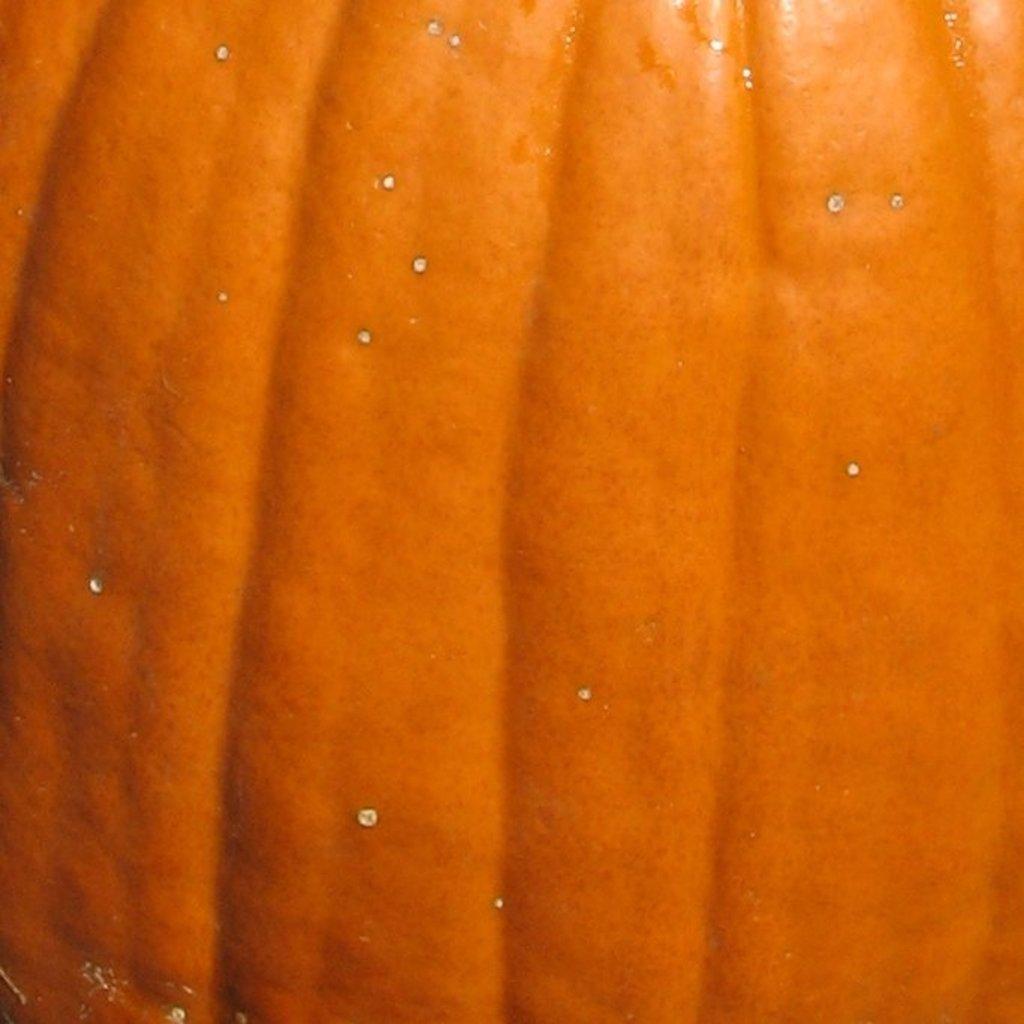Describe this image in one or two sentences. In this image we can see an orange object which looks like a pumpkin. 